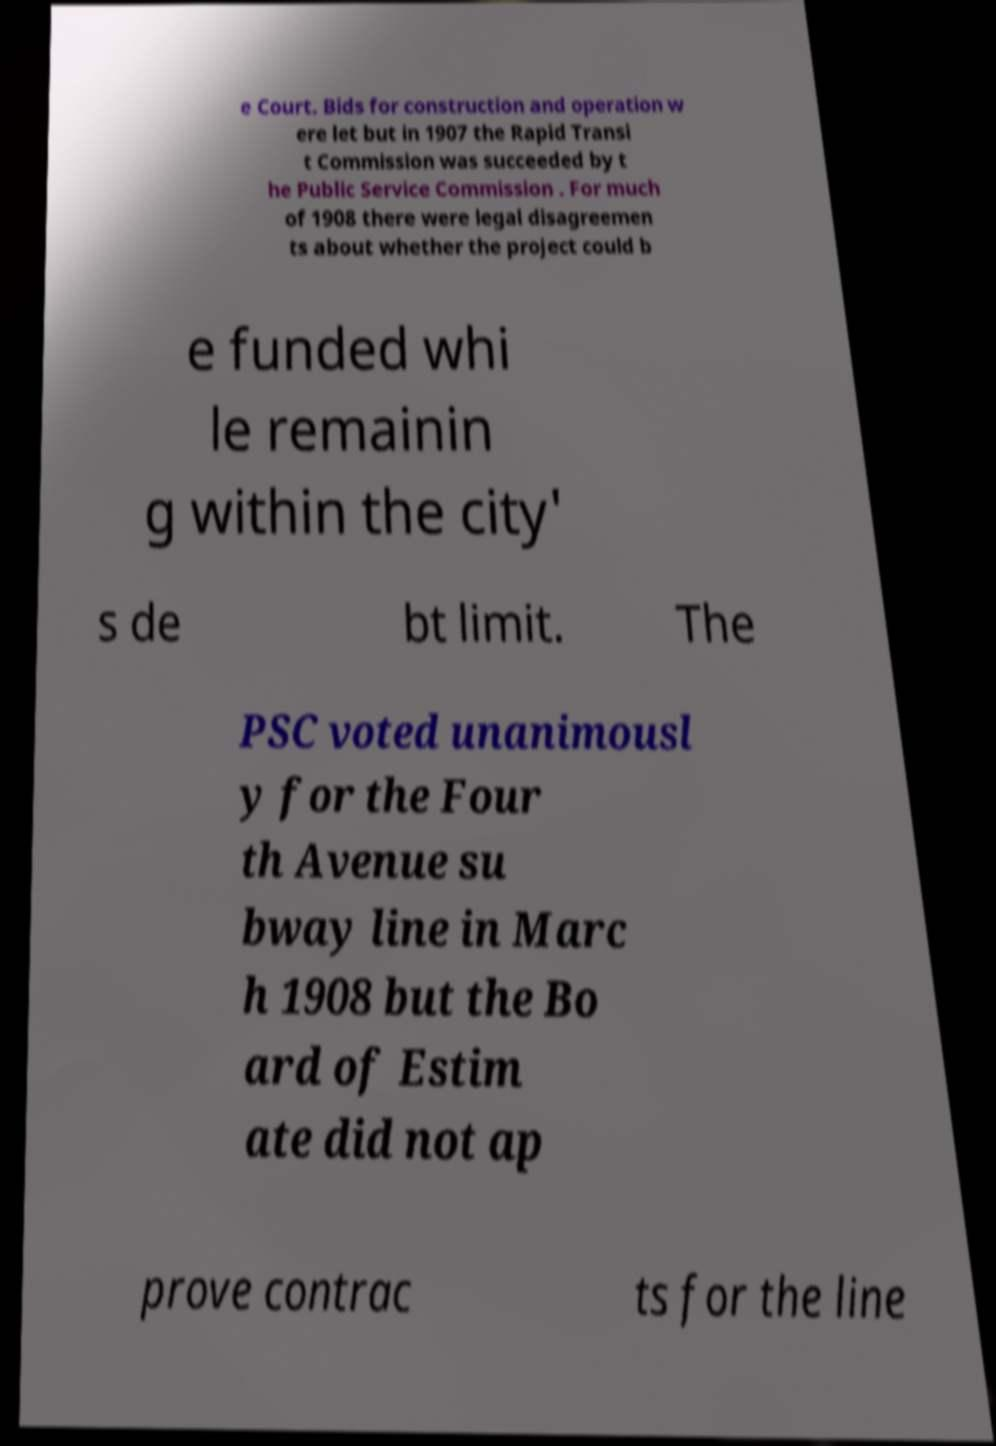Can you read and provide the text displayed in the image?This photo seems to have some interesting text. Can you extract and type it out for me? e Court. Bids for construction and operation w ere let but in 1907 the Rapid Transi t Commission was succeeded by t he Public Service Commission . For much of 1908 there were legal disagreemen ts about whether the project could b e funded whi le remainin g within the city' s de bt limit. The PSC voted unanimousl y for the Four th Avenue su bway line in Marc h 1908 but the Bo ard of Estim ate did not ap prove contrac ts for the line 